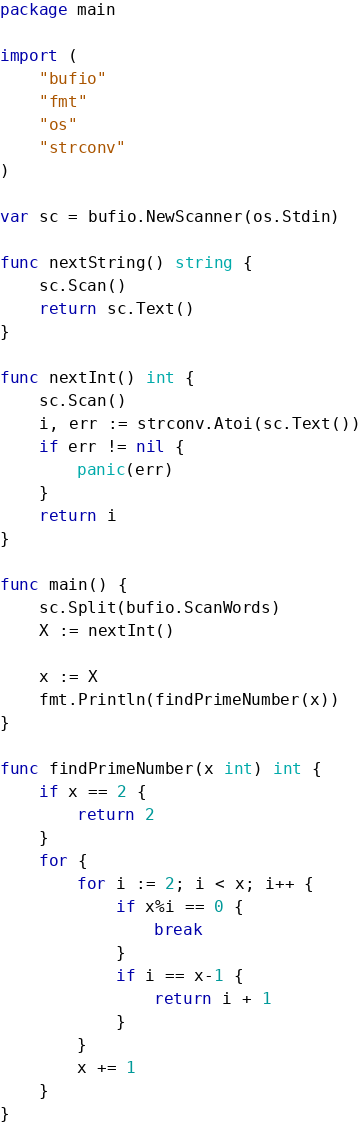<code> <loc_0><loc_0><loc_500><loc_500><_Go_>package main

import (
	"bufio"
	"fmt"
	"os"
	"strconv"
)

var sc = bufio.NewScanner(os.Stdin)

func nextString() string {
	sc.Scan()
	return sc.Text()
}

func nextInt() int {
	sc.Scan()
	i, err := strconv.Atoi(sc.Text())
	if err != nil {
		panic(err)
	}
	return i
}

func main() {
	sc.Split(bufio.ScanWords)
	X := nextInt()

	x := X
	fmt.Println(findPrimeNumber(x))
}

func findPrimeNumber(x int) int {
	if x == 2 {
		return 2
	}
	for {
		for i := 2; i < x; i++ {
			if x%i == 0 {
				break
			}
			if i == x-1 {
				return i + 1
			}
		}
		x += 1
	}
}
</code> 